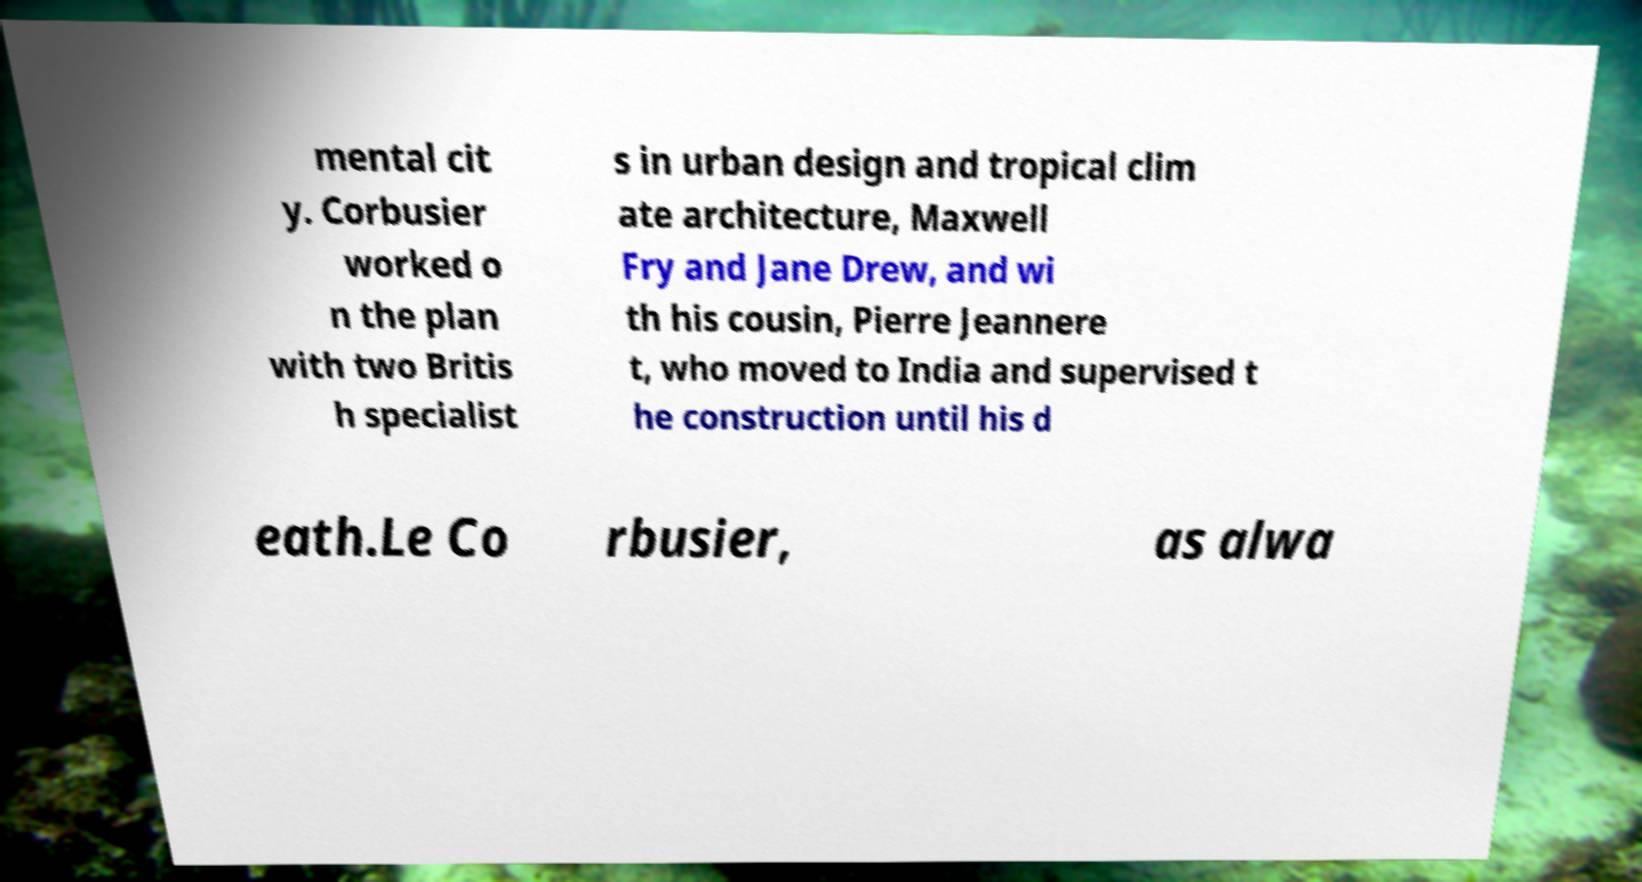Please read and relay the text visible in this image. What does it say? mental cit y. Corbusier worked o n the plan with two Britis h specialist s in urban design and tropical clim ate architecture, Maxwell Fry and Jane Drew, and wi th his cousin, Pierre Jeannere t, who moved to India and supervised t he construction until his d eath.Le Co rbusier, as alwa 